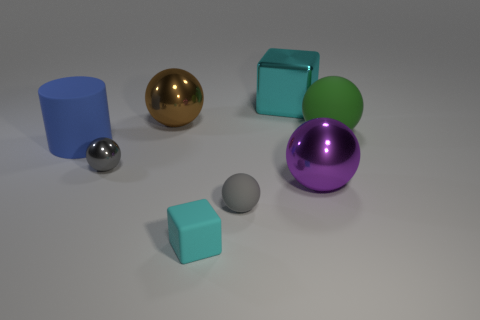Subtract all large brown spheres. How many spheres are left? 4 Subtract all brown spheres. How many spheres are left? 4 Subtract 3 balls. How many balls are left? 2 Subtract all brown balls. Subtract all green cubes. How many balls are left? 4 Add 1 large purple objects. How many objects exist? 9 Subtract all blocks. How many objects are left? 6 Subtract 0 green blocks. How many objects are left? 8 Subtract all big metal balls. Subtract all big rubber balls. How many objects are left? 5 Add 3 large objects. How many large objects are left? 8 Add 2 large brown metal things. How many large brown metal things exist? 3 